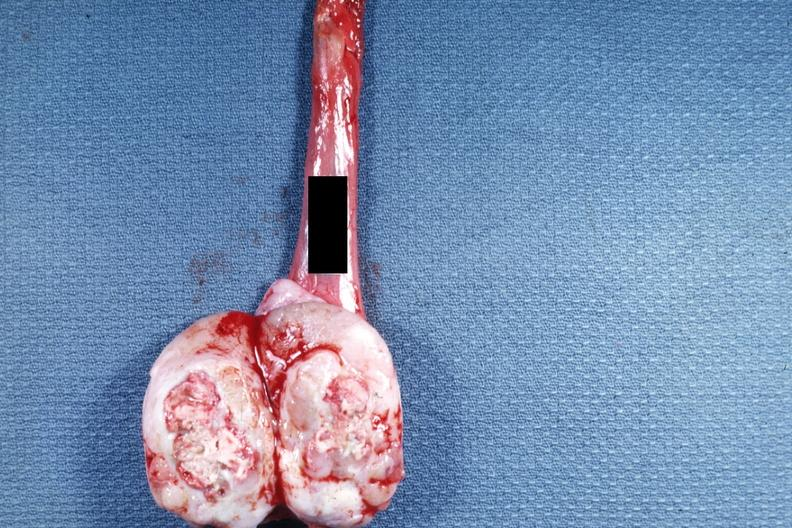what is present?
Answer the question using a single word or phrase. Testicle 